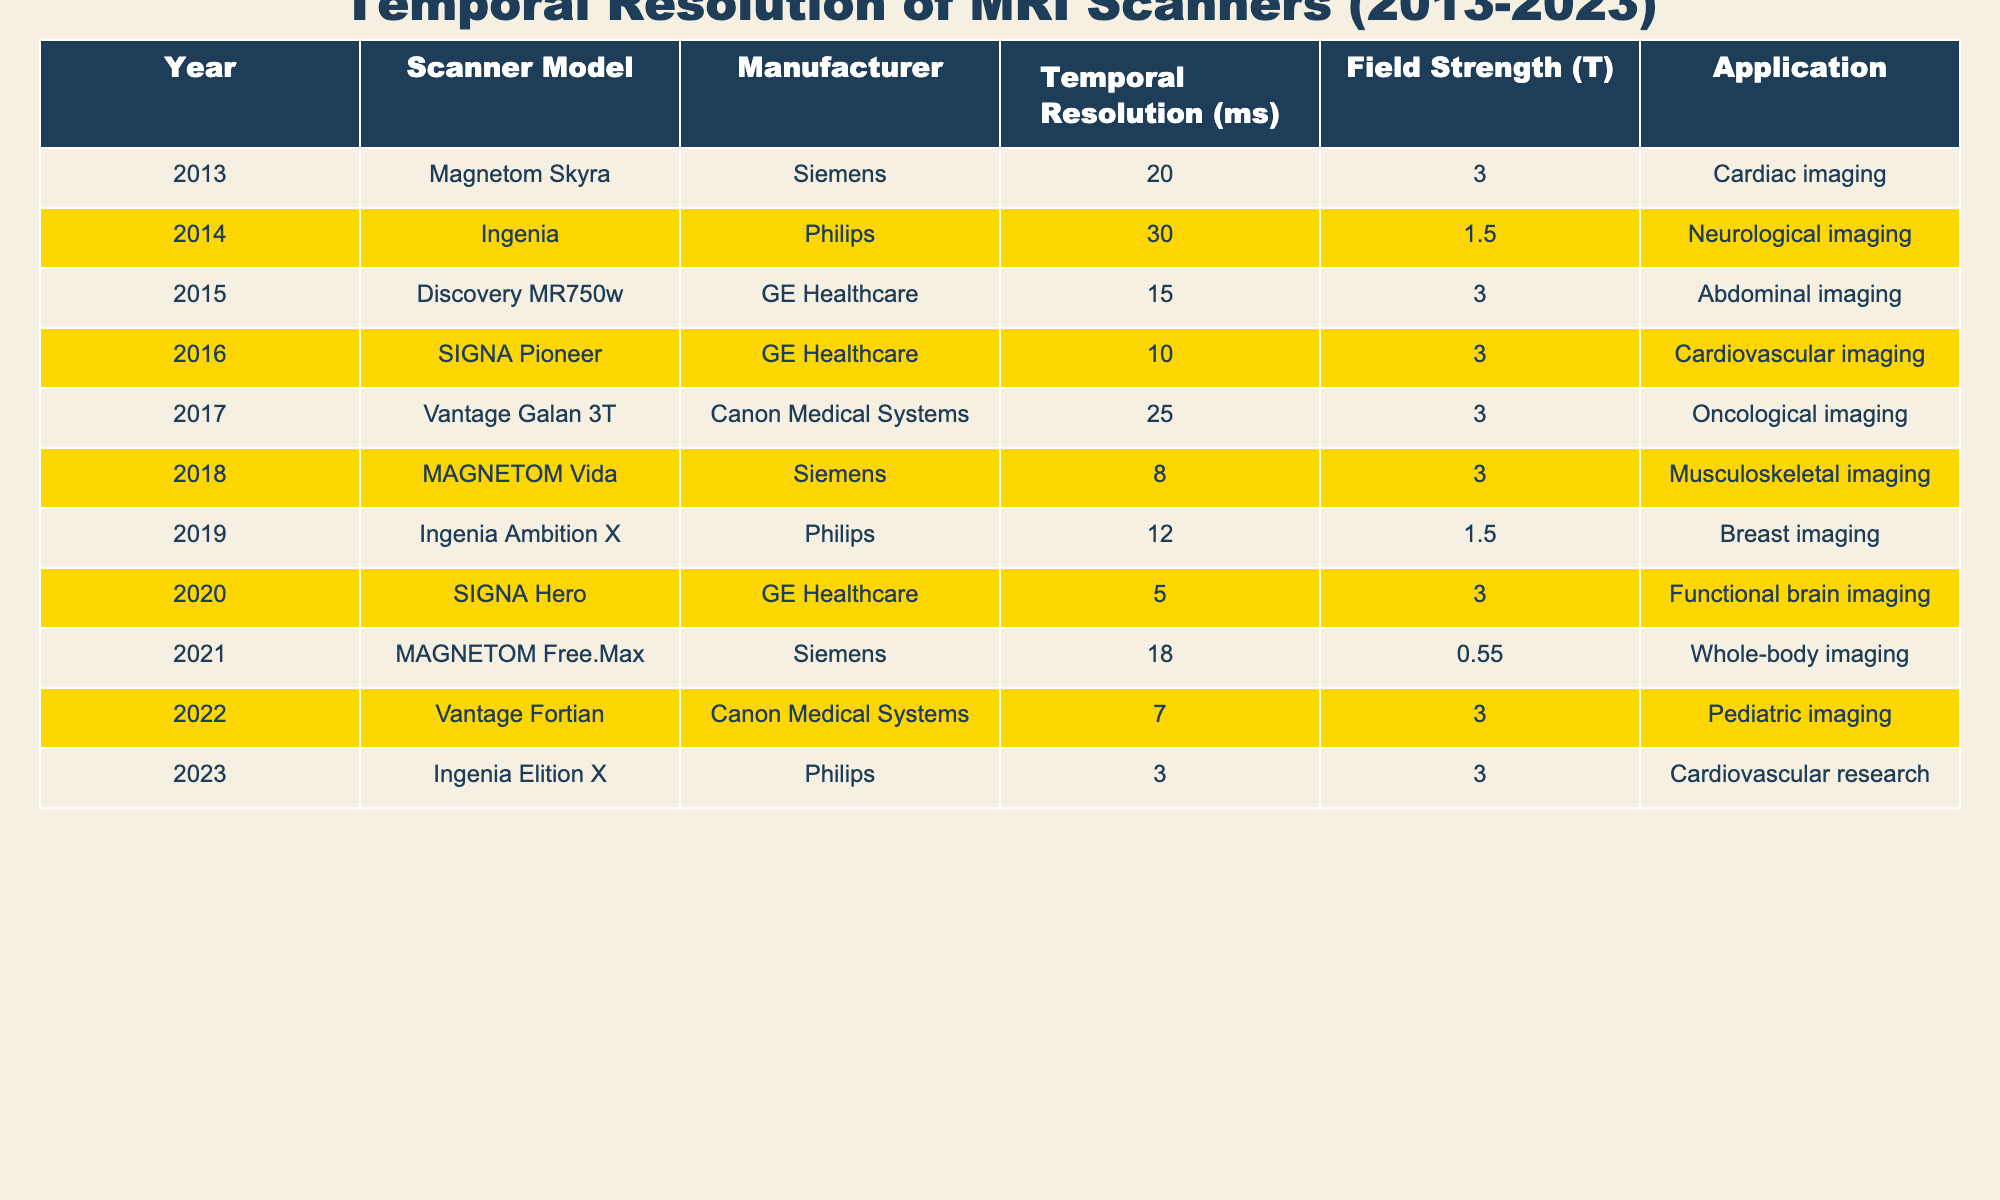What is the temporal resolution of the Ingenia scanner from Philips? The table lists the Ingenia scanner's temporal resolution in the year 2014 as 30 ms.
Answer: 30 ms Which MRI scanner has the highest temporal resolution? By examining the table, the Ingenia Elition X from Philips in 2023 has the highest temporal resolution of 3 ms.
Answer: 3 ms How many MRI scanners have a temporal resolution of less than 10 ms? Reviewing the table, there are three scanners with a temporal resolution of less than 10 ms: MAGNETOM Vida (8 ms), Vantage Fortian (7 ms), and Ingenia Elition X (3 ms).
Answer: 3 What is the average temporal resolution of all scanners in the table? By summing all the temporal resolutions (20 + 30 + 15 + 10 + 25 + 8 + 12 + 5 + 18 + 7 + 3) =  153, and then dividing by the number of scanners (11), the average temporal resolution is 153/11 ≈ 13.91 ms.
Answer: 13.91 ms Did the temporal resolution improve over the decade from 2013 to 2023? Comparing the first scanner's temporal resolution in 2013 (20 ms) to the last scanner's in 2023 (3 ms), it shows a significant decrease in temporal resolution, indicating a trend towards better performance in newer models.
Answer: Yes Which manufacturer has the most diverse temporal resolutions based on this table? Analyzing the table, GE Healthcare offers scanners with a variety of temporal resolutions: 15 ms (2015), 10 ms (2016), and 5 ms (2020), making it the manufacturer with the most diverse specifications.
Answer: GE Healthcare What is the difference in temporal resolution between the 2018 and 2020 scanners? The 2018 scanner (MAGNETOM Vida) has a temporal resolution of 8 ms, while the 2020 scanner (SIGNA Hero) has a temporal resolution of 5 ms. The difference is 8 - 5 = 3 ms.
Answer: 3 ms How many years had a scanner with a temporal resolution below 15 ms? The years with a scanner temporal resolution below 15 ms are 2016 (10 ms), 2018 (8 ms), 2020 (5 ms), 2022 (7 ms), and 2023 (3 ms). That's a total of 5 years.
Answer: 5 years Which application had the lowest temporal resolution and what was it? The application with the lowest temporal resolution (3 ms) is cardiovascular research in the Ingenia Elition X from Philips for the year 2023.
Answer: Cardiovascular research Is there any scanner with a temporal resolution greater than 25 ms? Reviewing the data, the highest temporal resolution recorded is 30 ms from Ingenia in 2014, thus there is one scanner with a temporal resolution greater than 25 ms.
Answer: Yes 